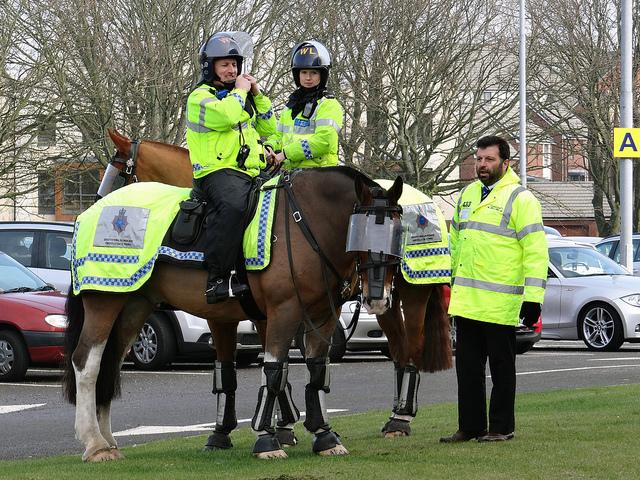What are the horses wearing?
Give a very brief answer. Blinders. Are these police officers?
Give a very brief answer. Yes. What color is the reflective tape on the jackets?
Write a very short answer. Silver. 